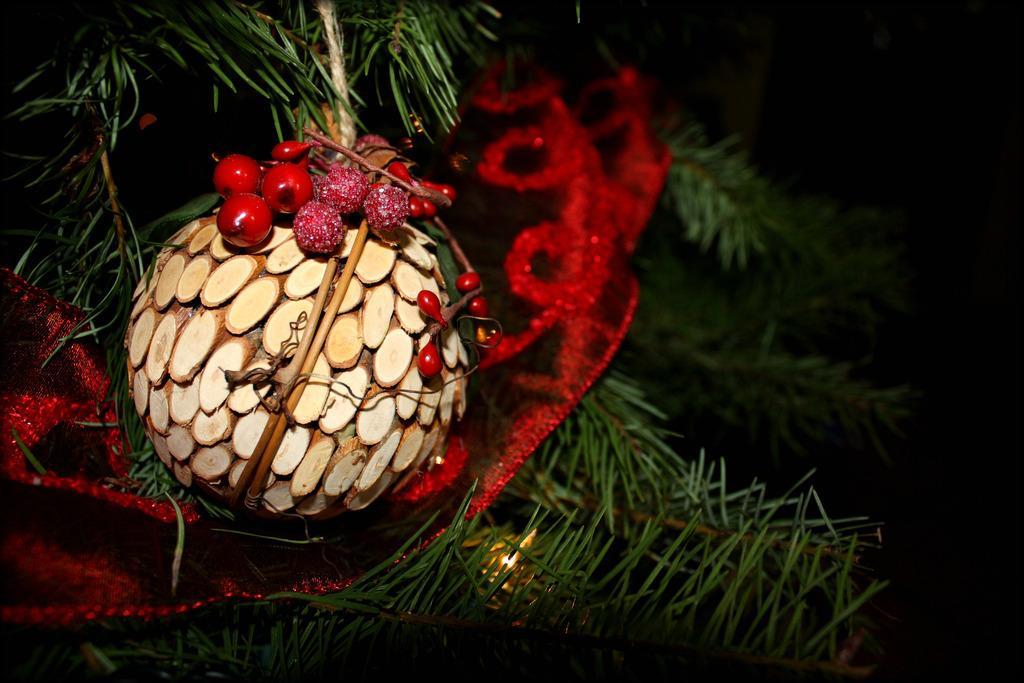Can you describe this image briefly? In this image there is a Christmas tree decorated with a few decorative items. 